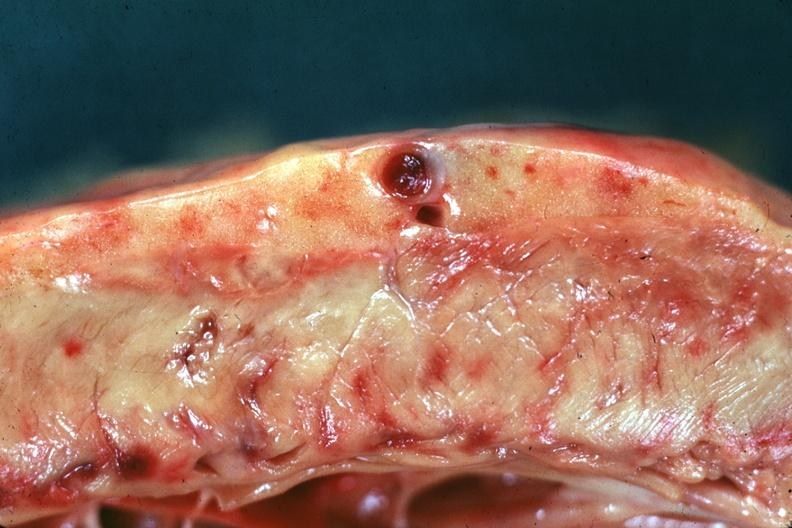what is present?
Answer the question using a single word or phrase. Prostate 